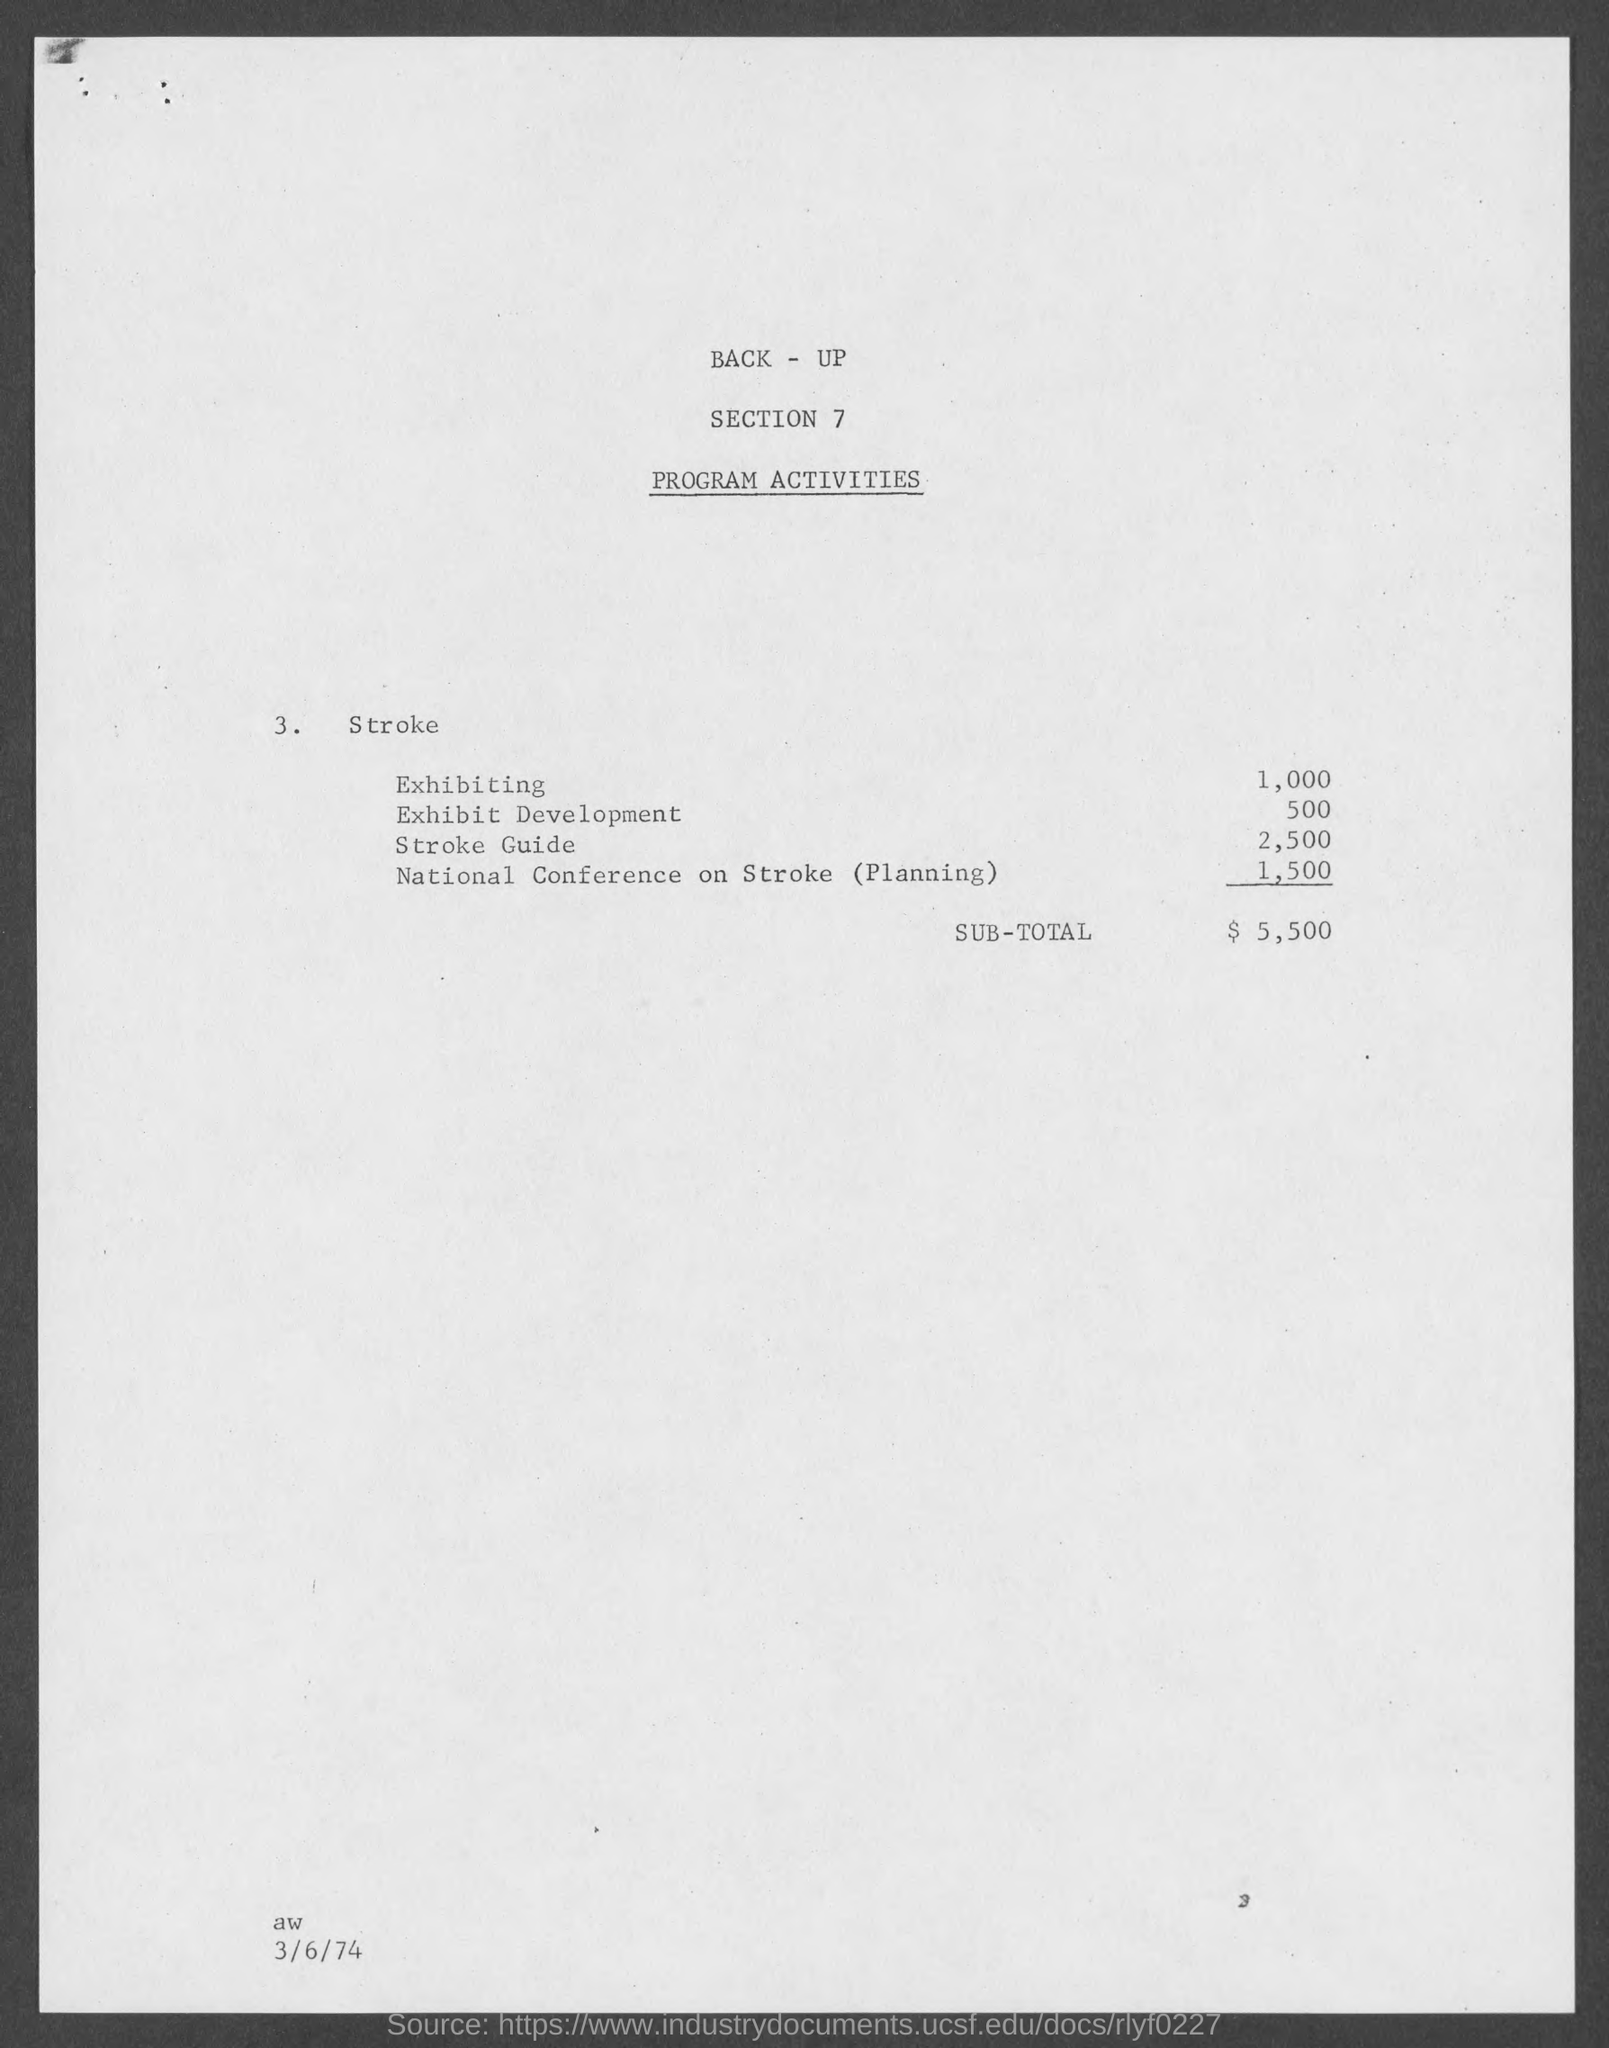Which section is mentioned?
Your answer should be very brief. 7. What is the amount corresponding to Stroke Guide?
Give a very brief answer. 2,500. What is the SUB-TOTAL amount?
Offer a terse response. $  5,500. 